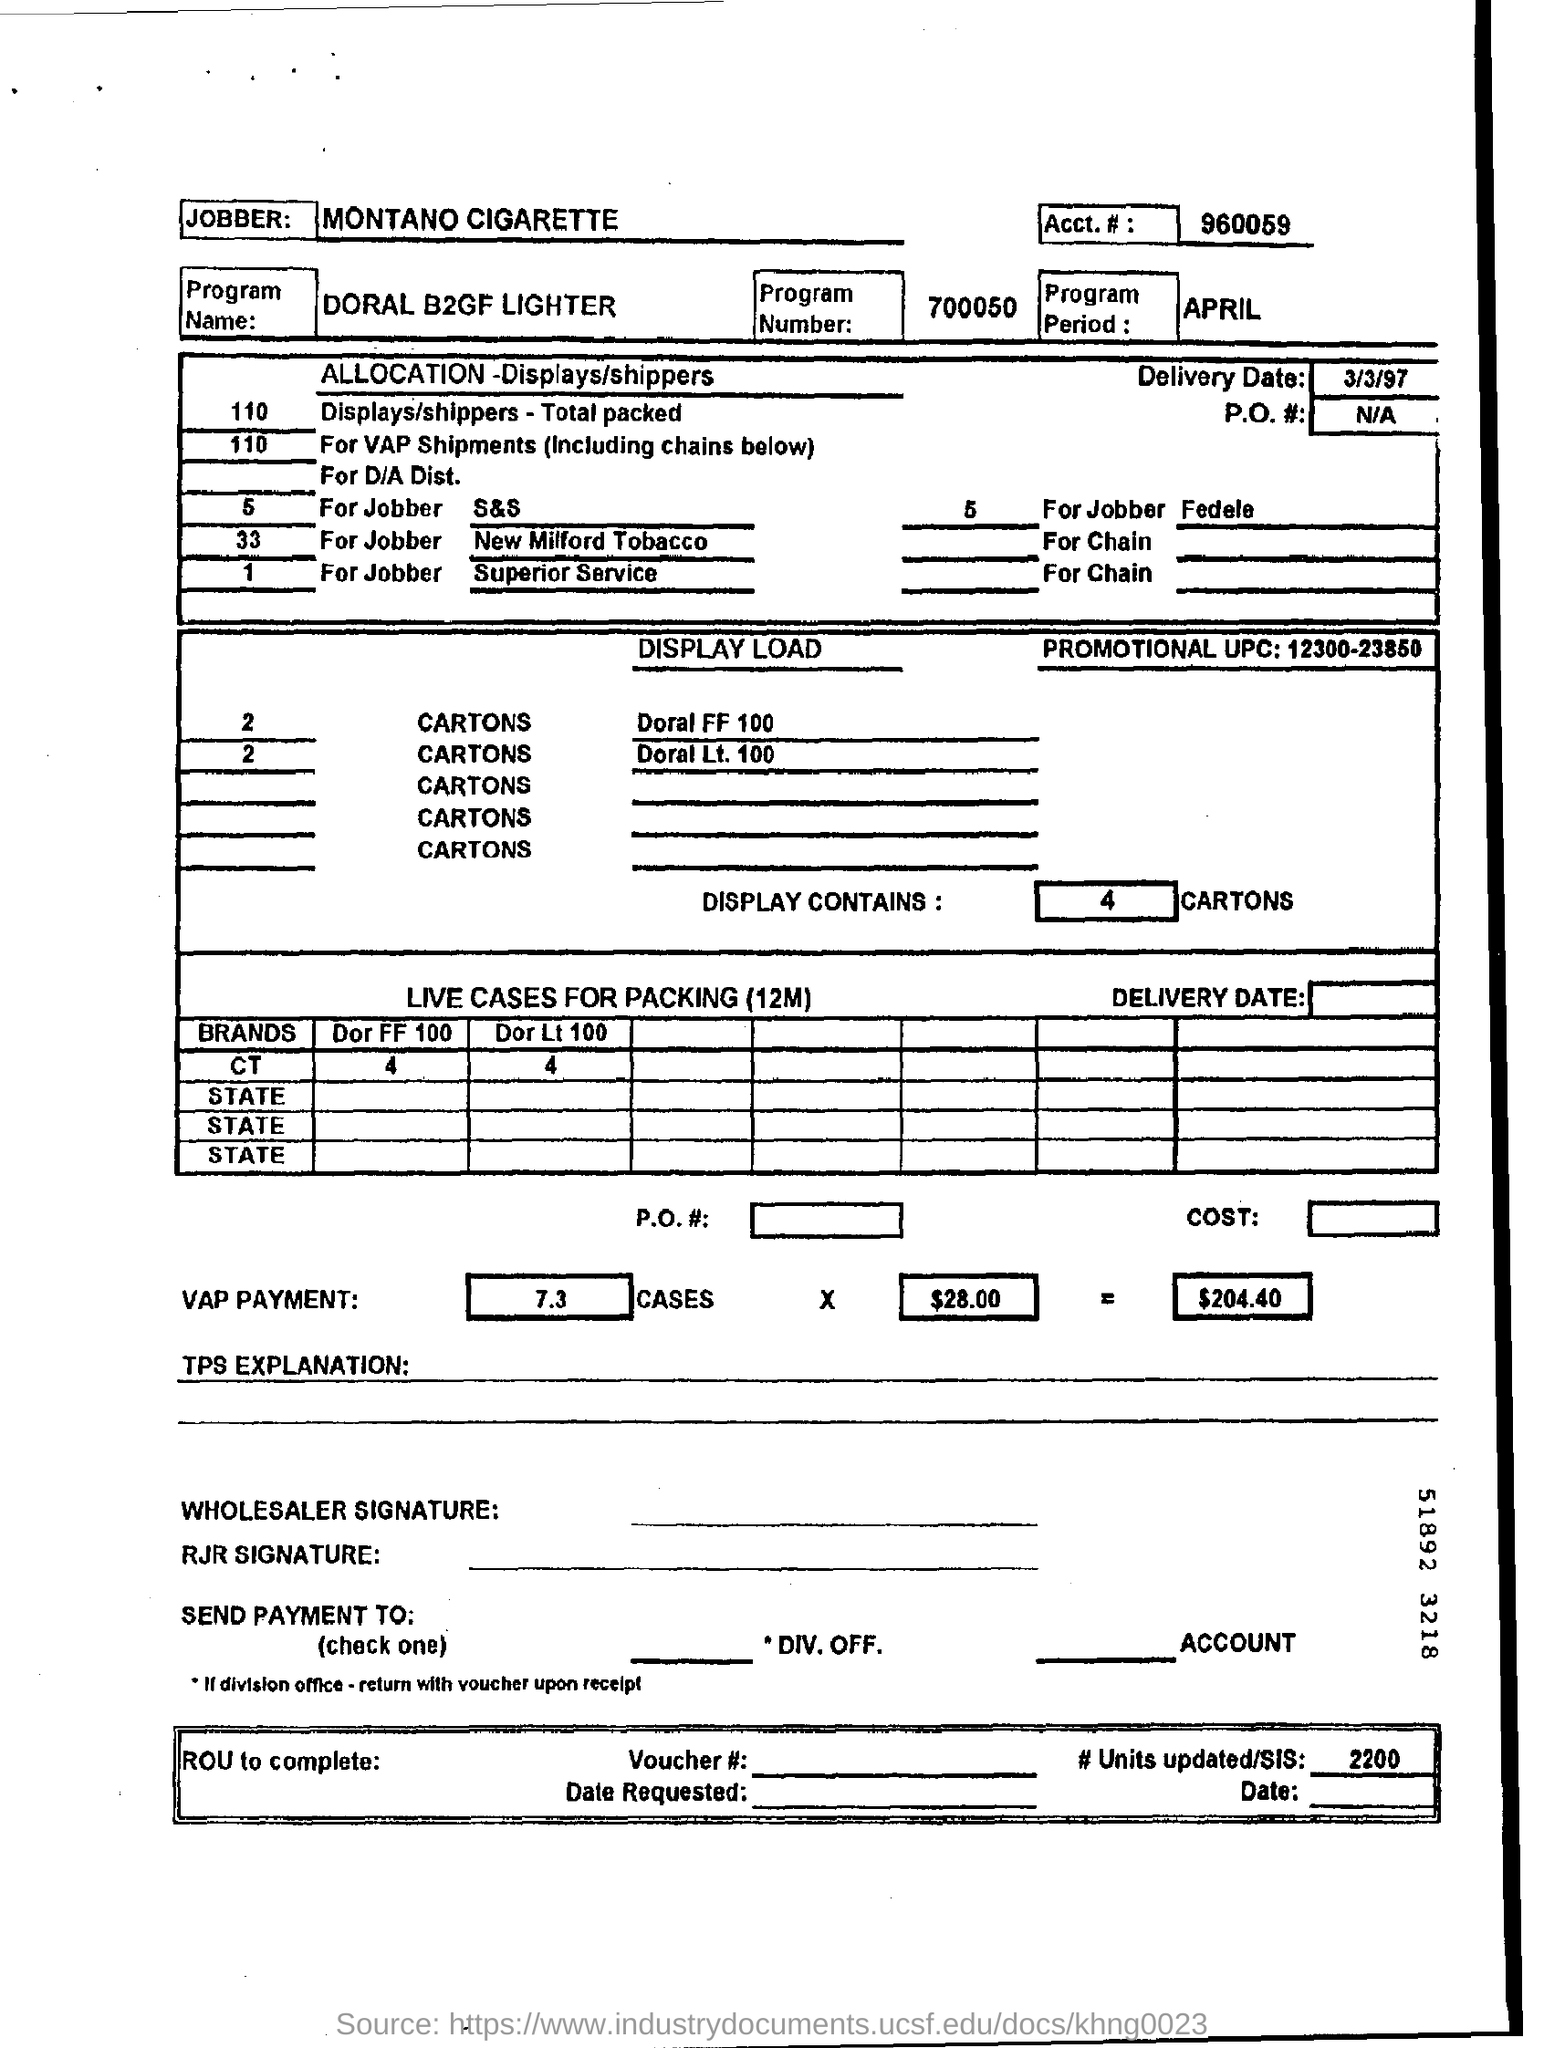Specify some key components in this picture. The promotional UPC mentioned in the document is 12300-23850. The number of units updated and the number of SIS given in the document are 2200. The account number given in the document is 960059. The delivery date provided in the document is March 3, 1997. The program mentioned in this document is the DORAL B2GF LIGHTER. 